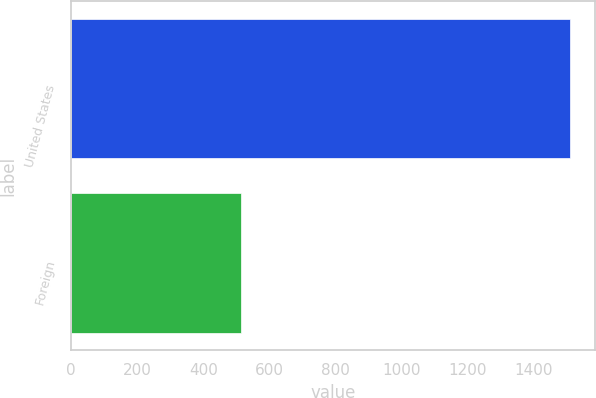<chart> <loc_0><loc_0><loc_500><loc_500><bar_chart><fcel>United States<fcel>Foreign<nl><fcel>1509<fcel>515<nl></chart> 